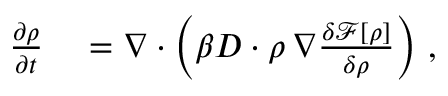<formula> <loc_0><loc_0><loc_500><loc_500>\begin{array} { r l } { \frac { \partial \rho } { \partial t } } & = \nabla \cdot \left ( \beta D \cdot \rho \, \nabla \frac { \delta \mathcal { F [ \rho ] } } { \delta \rho } \right ) \, , } \end{array}</formula> 